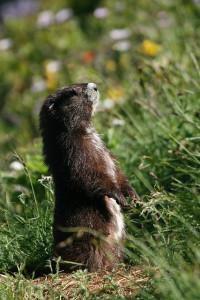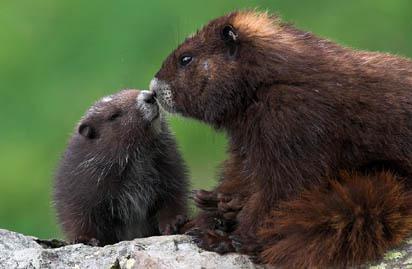The first image is the image on the left, the second image is the image on the right. For the images displayed, is the sentence "We've got three groundhogs here." factually correct? Answer yes or no. Yes. The first image is the image on the left, the second image is the image on the right. For the images shown, is this caption "There are exactly three marmots." true? Answer yes or no. Yes. 